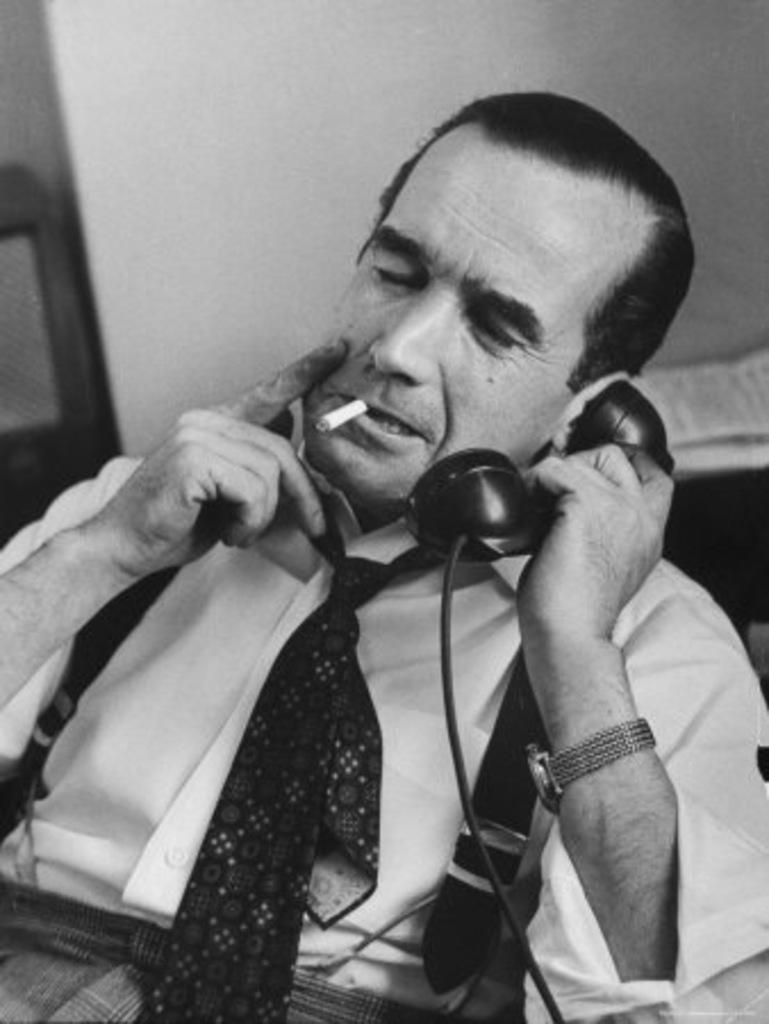Can you describe this image briefly? In this image we can see a person sitting and holding a telephone and a cigar in his mouth. 